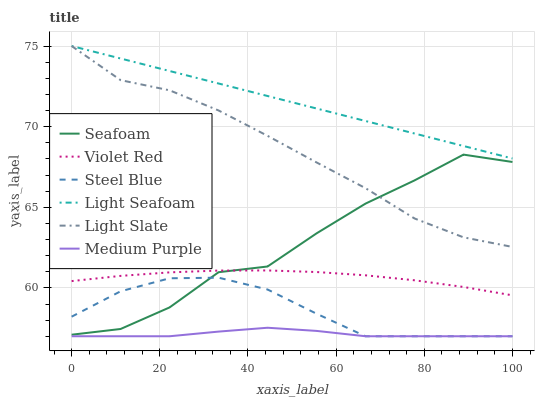Does Medium Purple have the minimum area under the curve?
Answer yes or no. Yes. Does Light Seafoam have the maximum area under the curve?
Answer yes or no. Yes. Does Light Slate have the minimum area under the curve?
Answer yes or no. No. Does Light Slate have the maximum area under the curve?
Answer yes or no. No. Is Light Seafoam the smoothest?
Answer yes or no. Yes. Is Seafoam the roughest?
Answer yes or no. Yes. Is Light Slate the smoothest?
Answer yes or no. No. Is Light Slate the roughest?
Answer yes or no. No. Does Steel Blue have the lowest value?
Answer yes or no. Yes. Does Light Slate have the lowest value?
Answer yes or no. No. Does Light Seafoam have the highest value?
Answer yes or no. Yes. Does Seafoam have the highest value?
Answer yes or no. No. Is Medium Purple less than Seafoam?
Answer yes or no. Yes. Is Light Slate greater than Medium Purple?
Answer yes or no. Yes. Does Seafoam intersect Violet Red?
Answer yes or no. Yes. Is Seafoam less than Violet Red?
Answer yes or no. No. Is Seafoam greater than Violet Red?
Answer yes or no. No. Does Medium Purple intersect Seafoam?
Answer yes or no. No. 